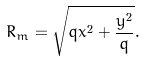<formula> <loc_0><loc_0><loc_500><loc_500>R _ { m } = \sqrt { q x ^ { 2 } + \frac { y ^ { 2 } } { q } } .</formula> 